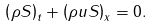<formula> <loc_0><loc_0><loc_500><loc_500>\left ( \rho S \right ) _ { t } + \left ( \rho u S \right ) _ { x } = 0 .</formula> 